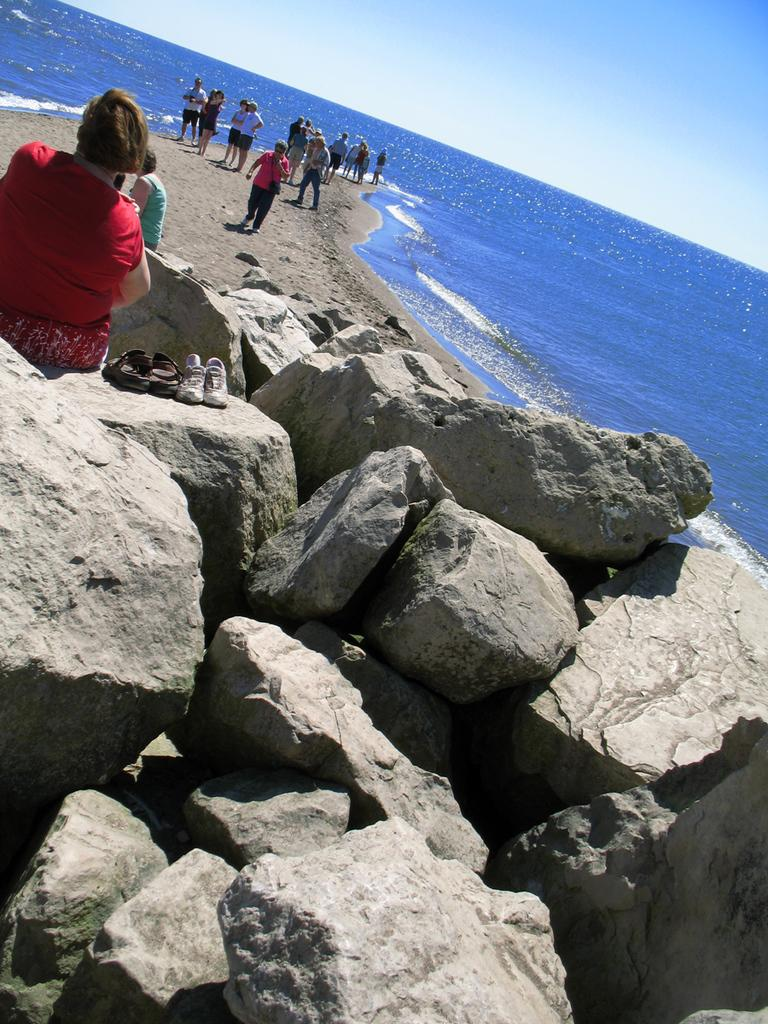What type of natural formation can be seen in the image? There are rocks in the image. What is the person sitting on in the image? The person is sitting on the rocks. What type of clothing or accessory is visible in the image? There is footwear visible in the image. What is the surface that the people standing on in the image? The people are standing on the sand. What is the liquid element present in the image? Water is present in the image. What is the color of the sky in the background of the image? The sky in the background is blue. What type of instrument is being played by the person sitting on the rocks in the image? There is no instrument being played in the image; the person is simply sitting on the rocks. Can you see a cup in the person's hand while sitting on the rocks? There is no cup visible in the person's hand in the image. 